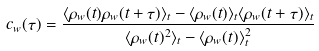Convert formula to latex. <formula><loc_0><loc_0><loc_500><loc_500>c _ { w } ( \tau ) = \frac { \langle \rho _ { w } ( t ) \rho _ { w } ( t + \tau ) \rangle _ { t } - \langle \rho _ { w } ( t ) \rangle _ { t } \langle \rho _ { w } ( t + \tau ) \rangle _ { t } } { \langle \rho _ { w } ( t ) ^ { 2 } \rangle _ { t } - \langle \rho _ { w } ( t ) \rangle _ { t } ^ { 2 } }</formula> 